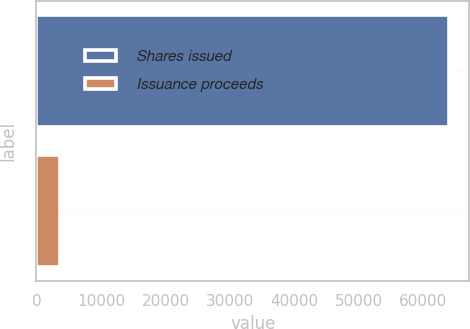Convert chart. <chart><loc_0><loc_0><loc_500><loc_500><bar_chart><fcel>Shares issued<fcel>Issuance proceeds<nl><fcel>63909<fcel>3686<nl></chart> 